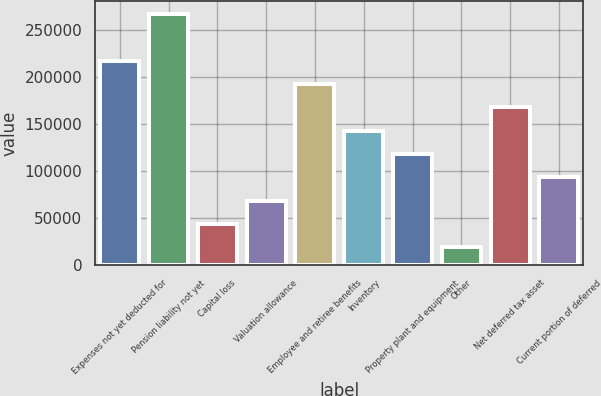<chart> <loc_0><loc_0><loc_500><loc_500><bar_chart><fcel>Expenses not yet deducted for<fcel>Pension liability not yet<fcel>Capital loss<fcel>Valuation allowance<fcel>Employee and retiree benefits<fcel>Inventory<fcel>Property plant and equipment<fcel>Other<fcel>Net deferred tax asset<fcel>Current portion of deferred<nl><fcel>217845<fcel>267544<fcel>43896.7<fcel>68746.4<fcel>192995<fcel>143296<fcel>118446<fcel>19047<fcel>168145<fcel>93596.1<nl></chart> 